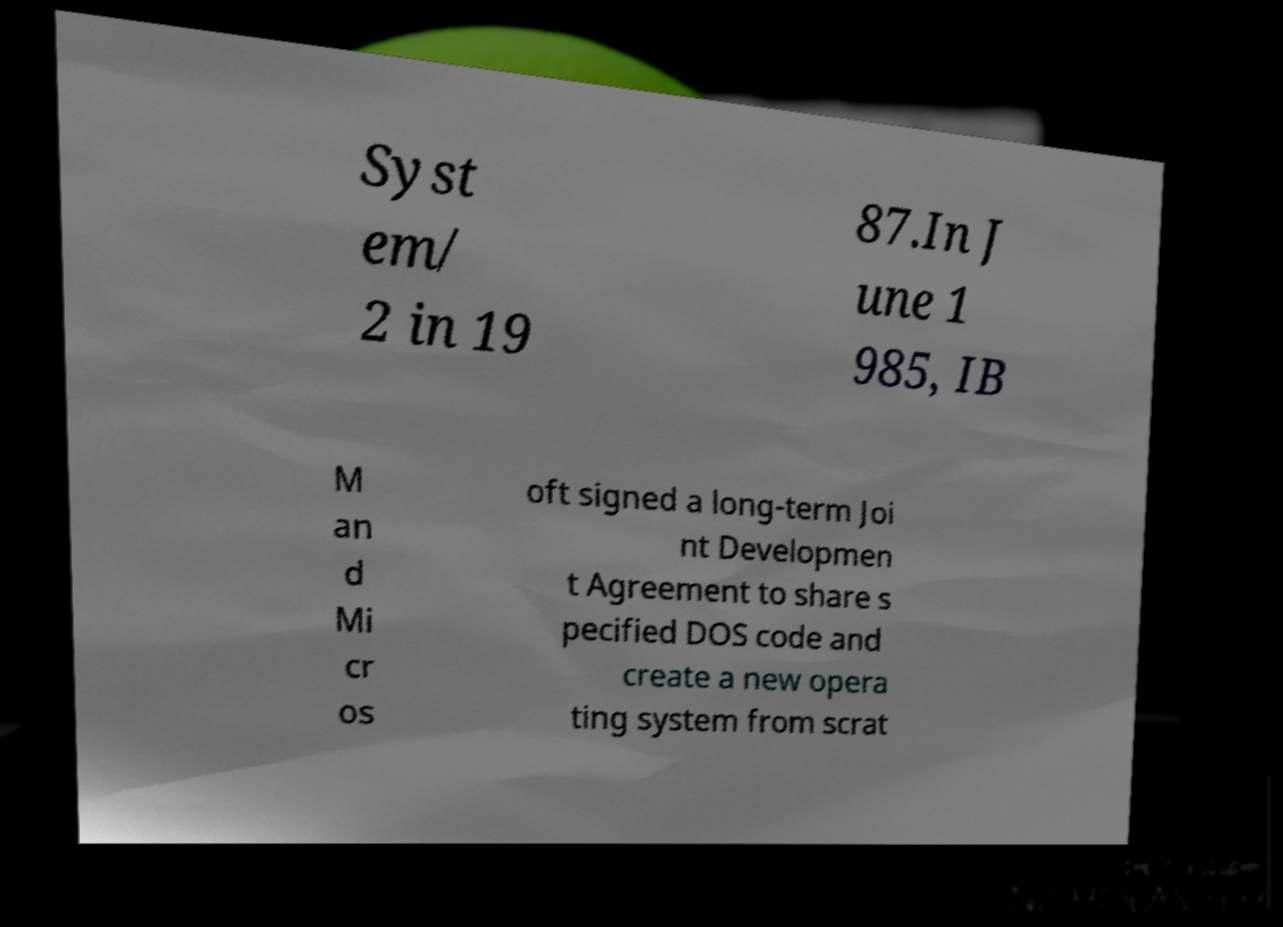What messages or text are displayed in this image? I need them in a readable, typed format. Syst em/ 2 in 19 87.In J une 1 985, IB M an d Mi cr os oft signed a long-term Joi nt Developmen t Agreement to share s pecified DOS code and create a new opera ting system from scrat 